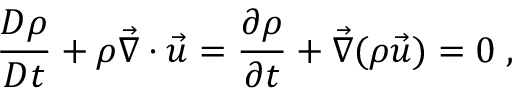<formula> <loc_0><loc_0><loc_500><loc_500>\frac { D \rho } { D t } + \rho \vec { \nabla } \cdot \vec { u } = \frac { \partial \rho } { \partial t } + \vec { \nabla } ( \rho \vec { u } ) = 0 \, ,</formula> 